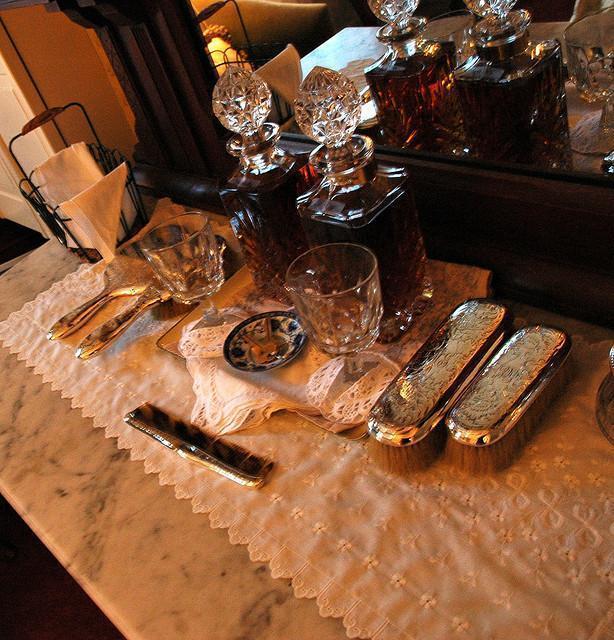What is most likely in the glass with the round top?
Answer the question by selecting the correct answer among the 4 following choices.
Options: Plasma, alcohol, tears, honey. Alcohol. 